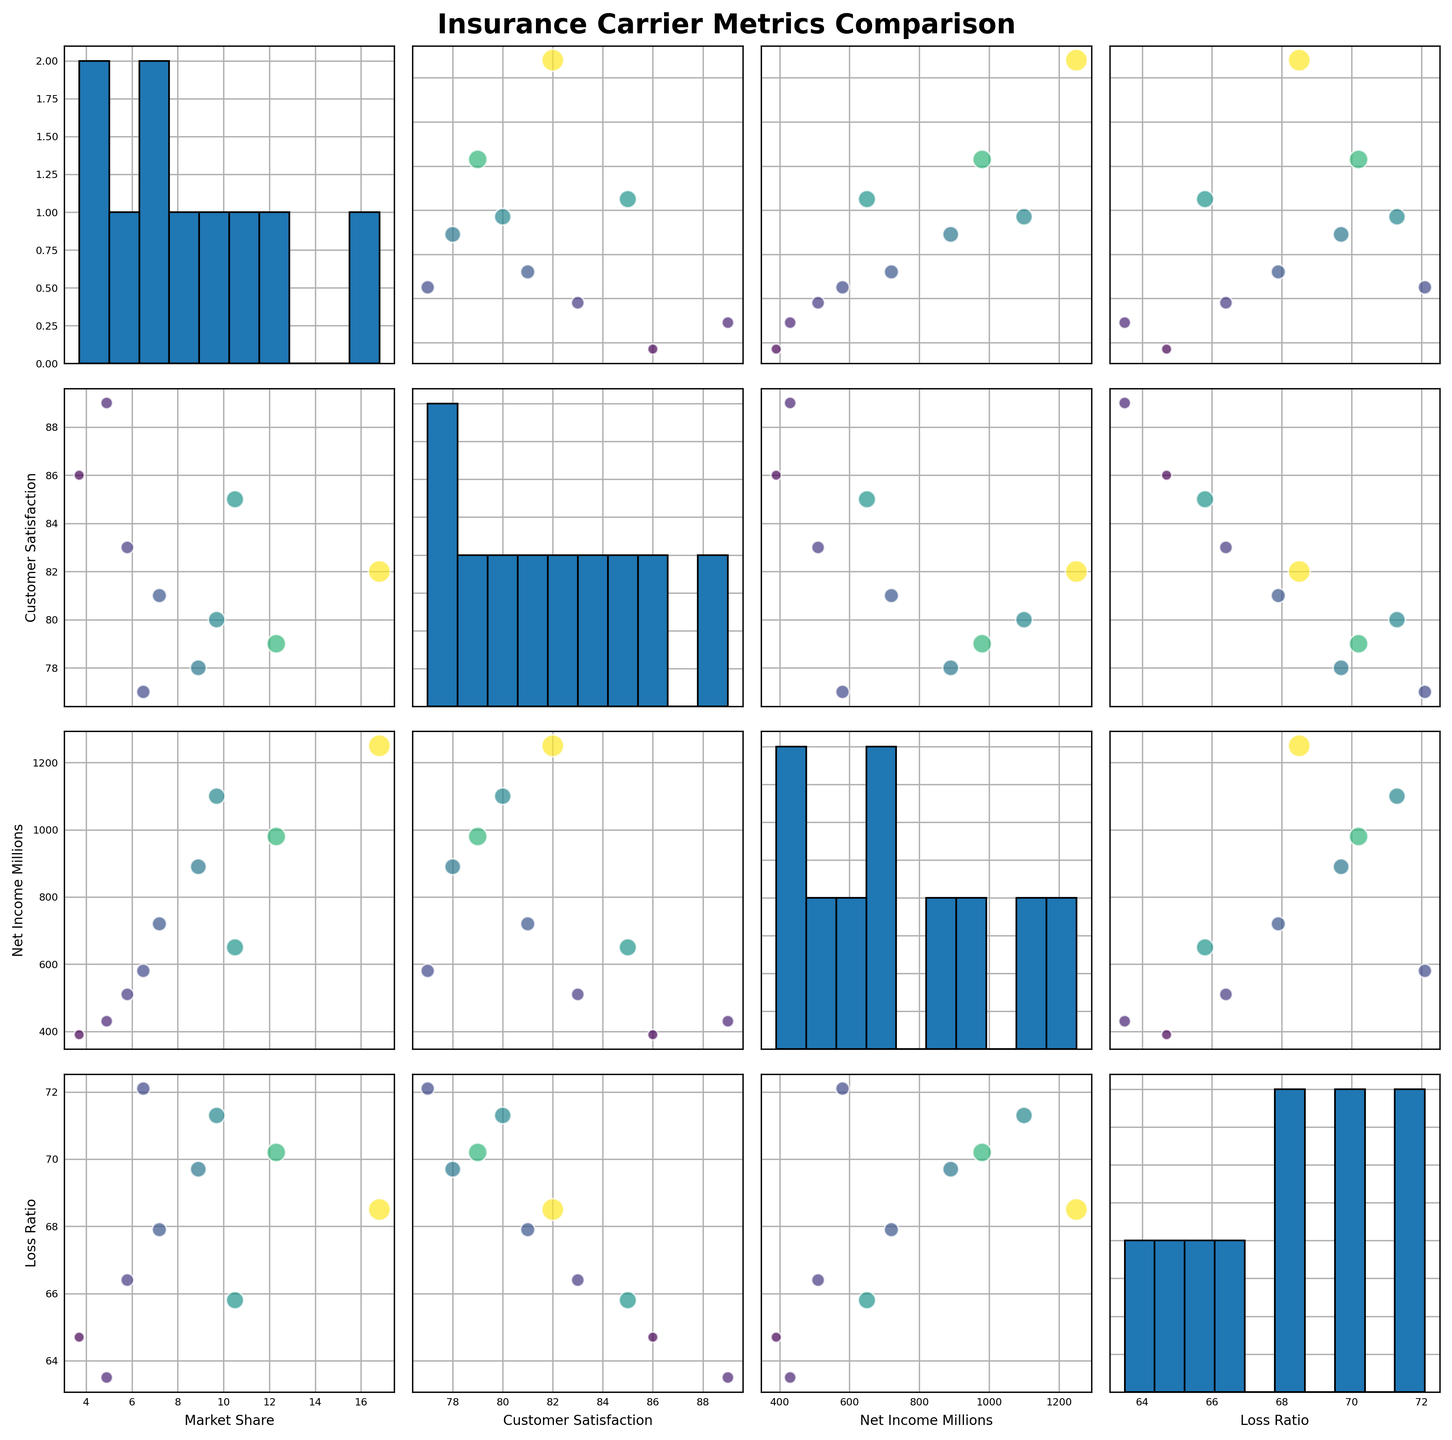What is the title of the figure? The title is typically at the top of the figure in bold text. The rendered figure has the title "Insurance Carrier Metrics Comparison," which is evident from the code's `fig.suptitle` argument.
Answer: Insurance Carrier Metrics Comparison How many variables are displayed in the scatterplot matrix? The variables are labels on the x-axes and y-axes of the subplots. From the code and the rendered figure, there are four variables: "Market Share," "Customer Satisfaction," "Net Income Millions," and "Loss Ratio."
Answer: Four Which insurance carrier has the highest customer satisfaction score? Customer satisfaction scores are on one of the axes, and we look for the highest point on plots involving this variable. USAA has the highest score of 89, as indicated by the dot at the highest position on the "Customer Satisfaction" axis.
Answer: USAA What is the most frequent range of market share among the carriers? The histogram on the diagonal for "Market Share" indicates frequency. The highest bar in the histogram represents the most frequent range. In the data provided, most carriers have Market Share ranging from 3.7 to 10.5, indicating this range is most frequent.
Answer: 3.7 to 10.5 Are there any carriers with both high customer satisfaction and low loss ratios? We look at scatterplots involving "Customer Satisfaction" and "Loss Ratio." Carriers in the upper left corner of such scatterplots meet this criterion. USAA, with a high satisfaction of 89 and a low loss ratio of 63.5, fits this description.
Answer: USAA Which carrier has a market share greater than 10 but a customer satisfaction score below 80? By comparing points in the scatterplots, Allstate (Market Share: 12.3, Satisfaction: 79) fits this criteria.
Answer: Allstate 